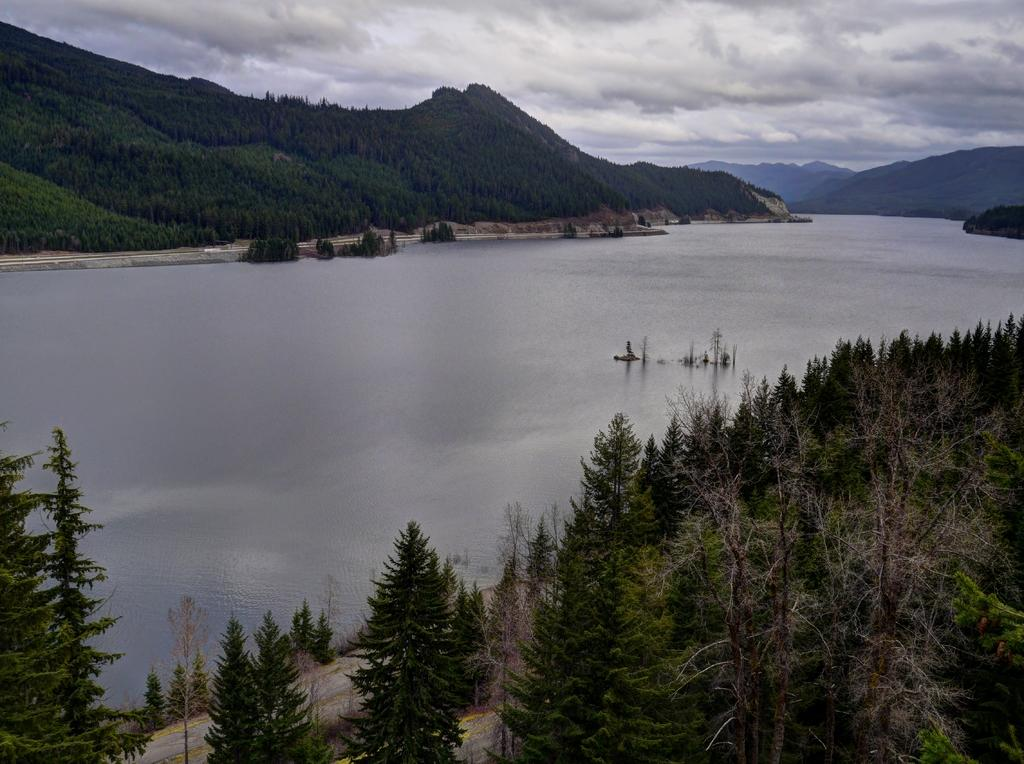What type of vegetation can be seen in the image? There are trees in the image. What natural element is visible in the image? There is water visible in the image. What can be seen in the background of the image? There are hills, trees, and the sky visible in the background of the image. What is the condition of the sky in the image? Clouds are present in the sky in the image. What hobbies do the trees in the image enjoy? Trees do not have hobbies, as they are inanimate objects. Can you tell me where the scarecrow is located in the image? There is no scarecrow present in the image. 